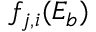<formula> <loc_0><loc_0><loc_500><loc_500>f _ { j , i } ( E _ { b } )</formula> 